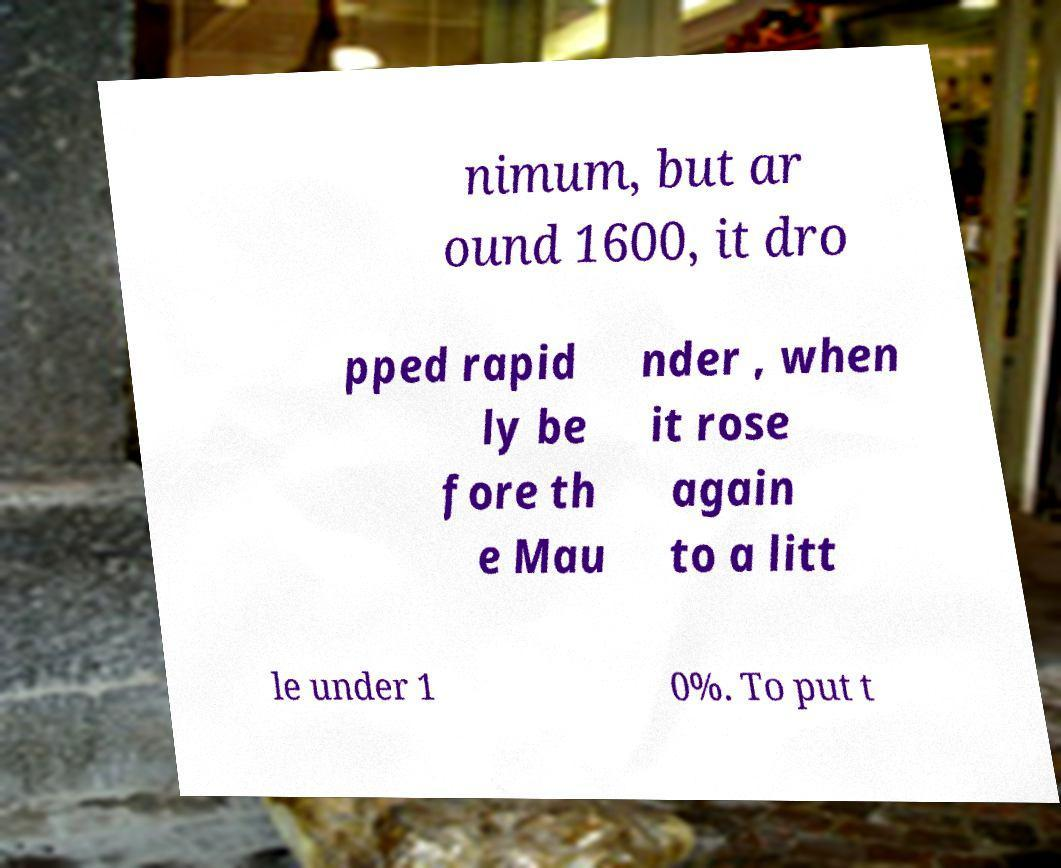Please identify and transcribe the text found in this image. nimum, but ar ound 1600, it dro pped rapid ly be fore th e Mau nder , when it rose again to a litt le under 1 0%. To put t 